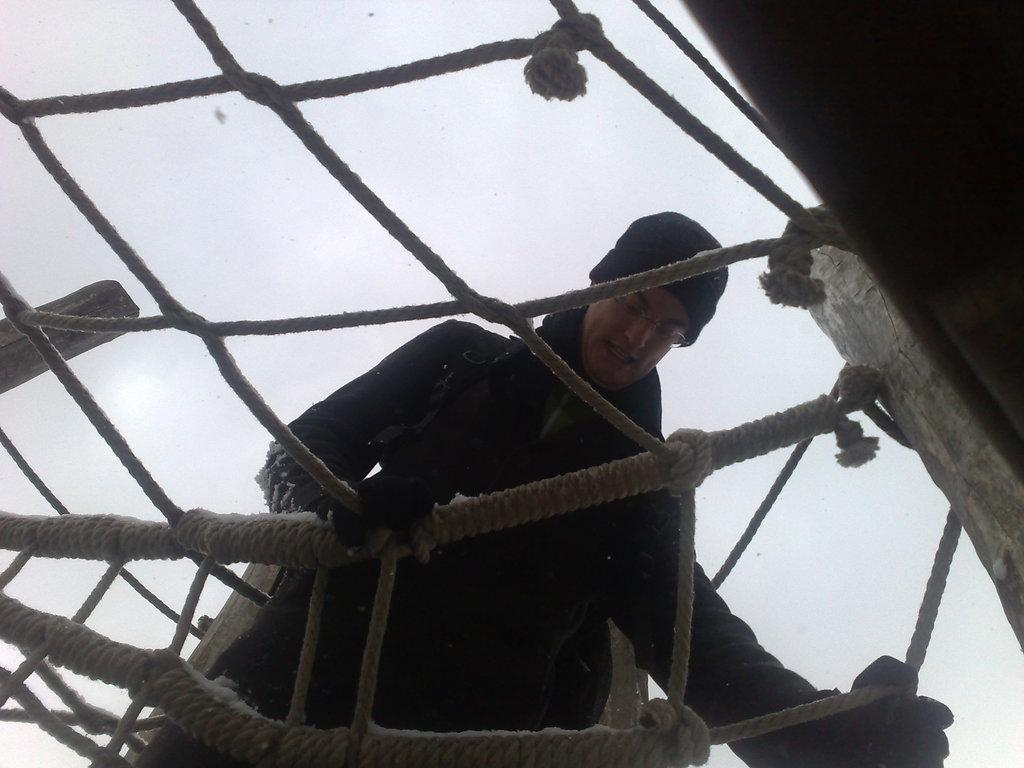What is the person in the image wearing? The person in the image is wearing a coat. What is the person doing in the image? The person is walking on a net. How is the net constructed? The net is made with threads that are connected with poles. What can be seen in the background of the image? The sky is visible in the background of the image. What type of wound can be seen on the person's hand in the image? There is no wound visible on the person's hand in the image. Is there a car parked near the person in the image? There is no car present in the image. 